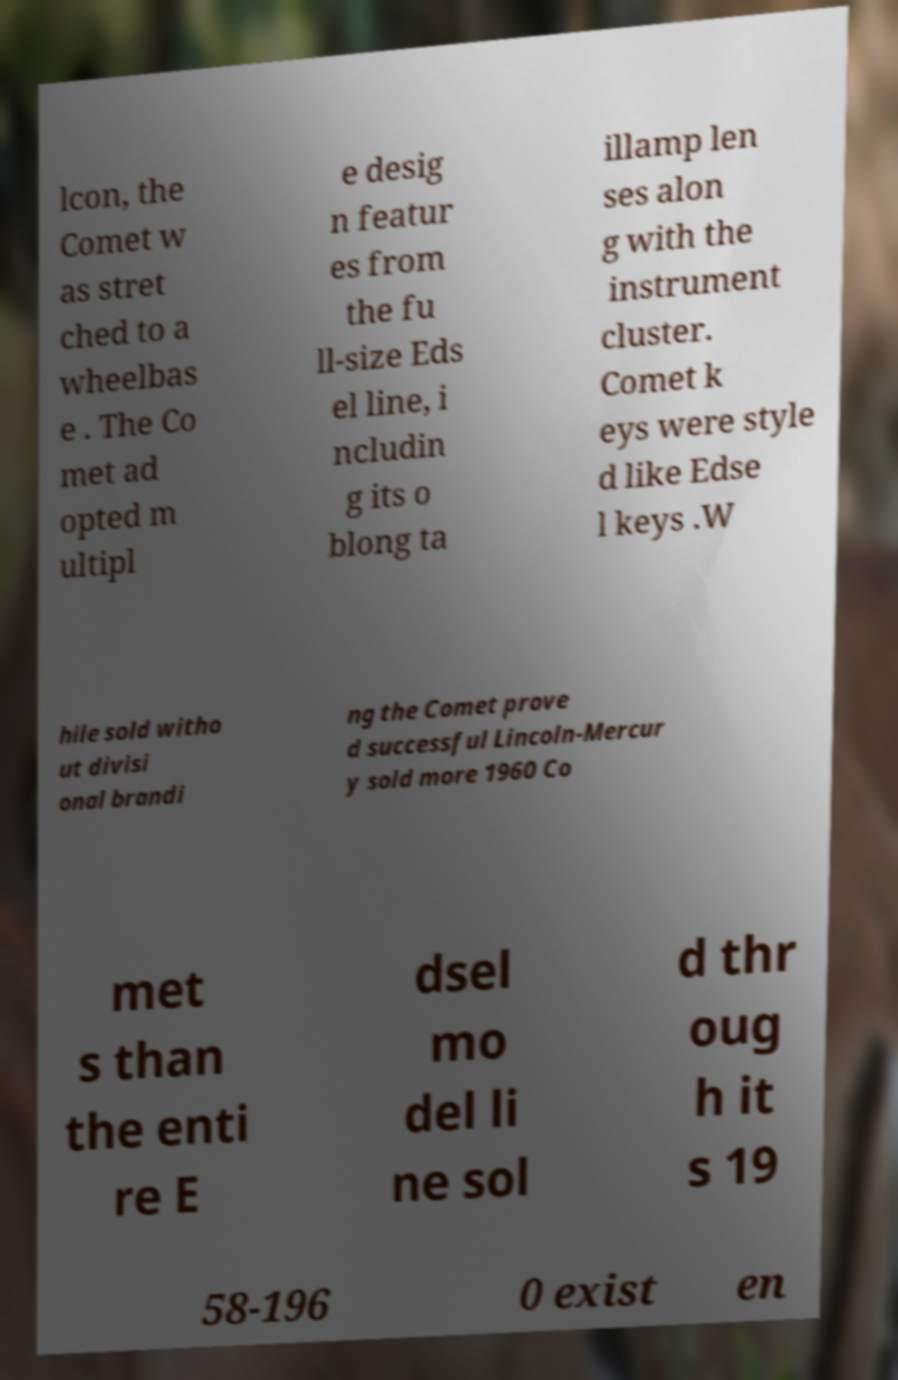For documentation purposes, I need the text within this image transcribed. Could you provide that? lcon, the Comet w as stret ched to a wheelbas e . The Co met ad opted m ultipl e desig n featur es from the fu ll-size Eds el line, i ncludin g its o blong ta illamp len ses alon g with the instrument cluster. Comet k eys were style d like Edse l keys .W hile sold witho ut divisi onal brandi ng the Comet prove d successful Lincoln-Mercur y sold more 1960 Co met s than the enti re E dsel mo del li ne sol d thr oug h it s 19 58-196 0 exist en 